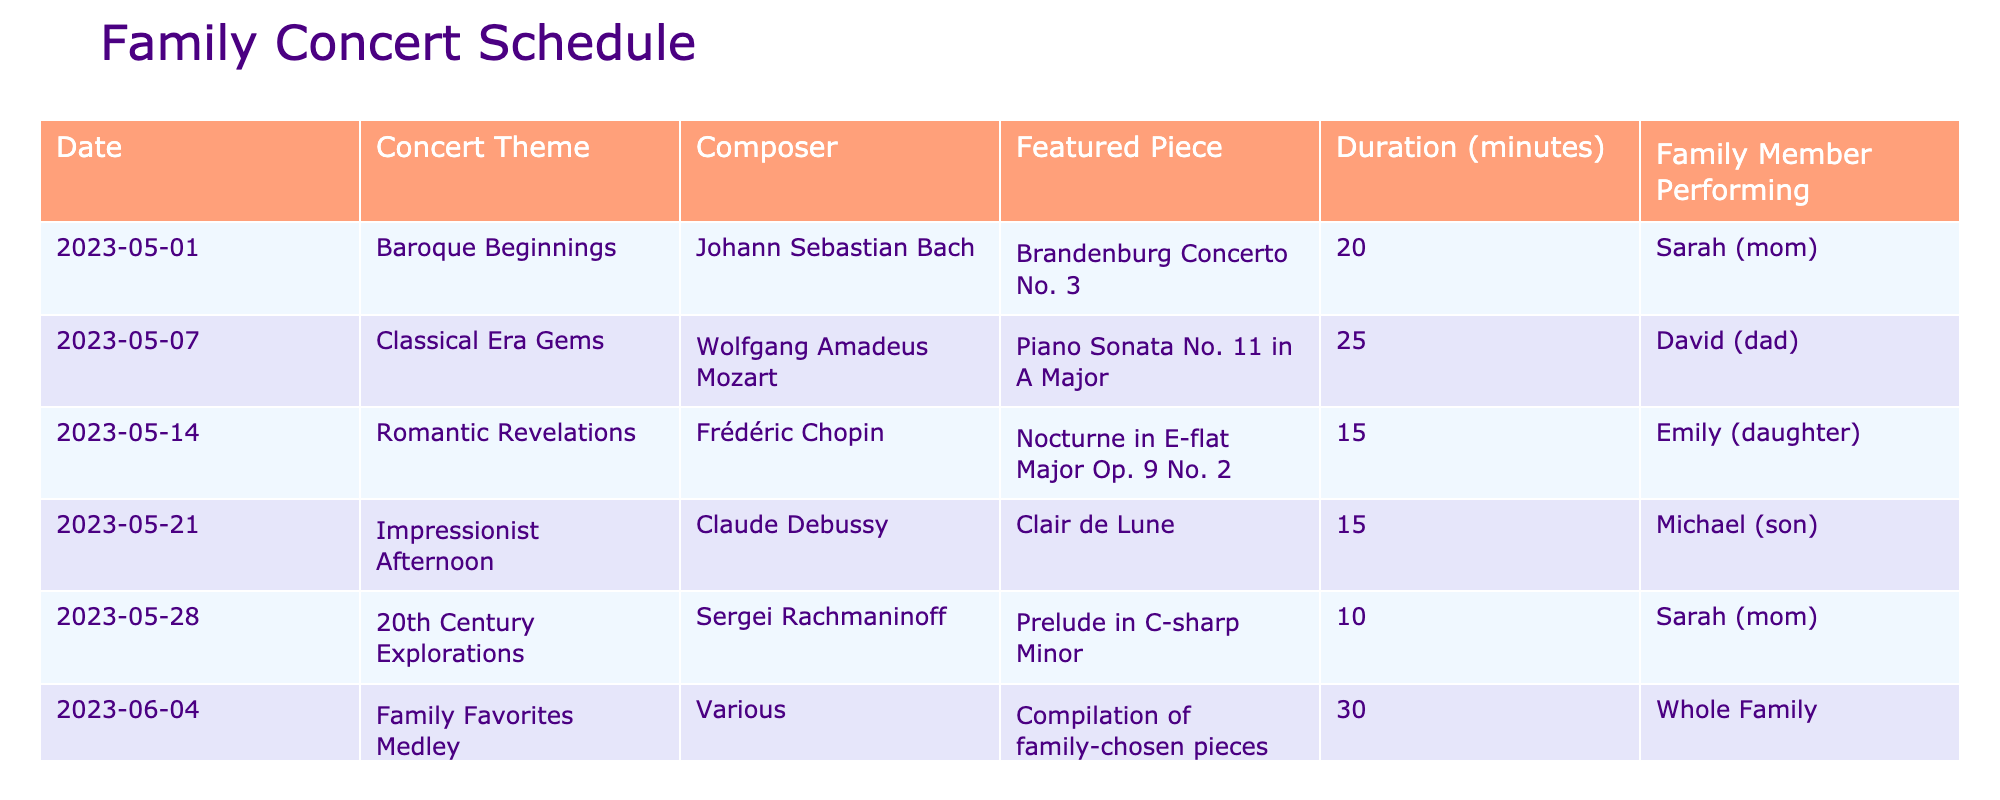What is the theme of the concert on May 14th? The table shows that the concert on May 14th is themed "Romantic Revelations."
Answer: Romantic Revelations Who is performing the "Brandenburg Concerto No. 3"? According to the table, Sarah (mom) is performing the "Brandenburg Concerto No. 3."
Answer: Sarah (mom) What is the total duration of all concerts scheduled in May? By adding the individual durations from each concert in May: 20 + 25 + 15 + 15 + 10 = 85 minutes.
Answer: 85 minutes Is there a concert featuring the whole family? Yes, the table indicates a concert titled "Family Favorites Medley" featuring the whole family on June 4th.
Answer: Yes Which composer is associated with the concert on May 7th? The table specifies that Wolfgang Amadeus Mozart is the composer for the concert on May 7th.
Answer: Wolfgang Amadeus Mozart What is the longest piece featured in the concerts? By comparing the durations of the featured pieces, the longest is the "Piano Sonata No. 11 in A Major" at 25 minutes on May 7th.
Answer: Piano Sonata No. 11 in A Major How many concerts are scheduled before June? There are five concerts scheduled before June, as listed from May 1st to May 28th.
Answer: 5 concerts Which concert has the shortest duration and what is it? The table shows that the "Prelude in C-sharp Minor" has the shortest duration at 10 minutes on May 28th.
Answer: Prelude in C-sharp Minor What percentage of concerts feature a single family member performing? Out of the six concerts, four are performed by a single family member (1, 2, 3, and 4) and two by the whole family, giving a percentage of (4/6) * 100 = 66.67%.
Answer: 66.67% 